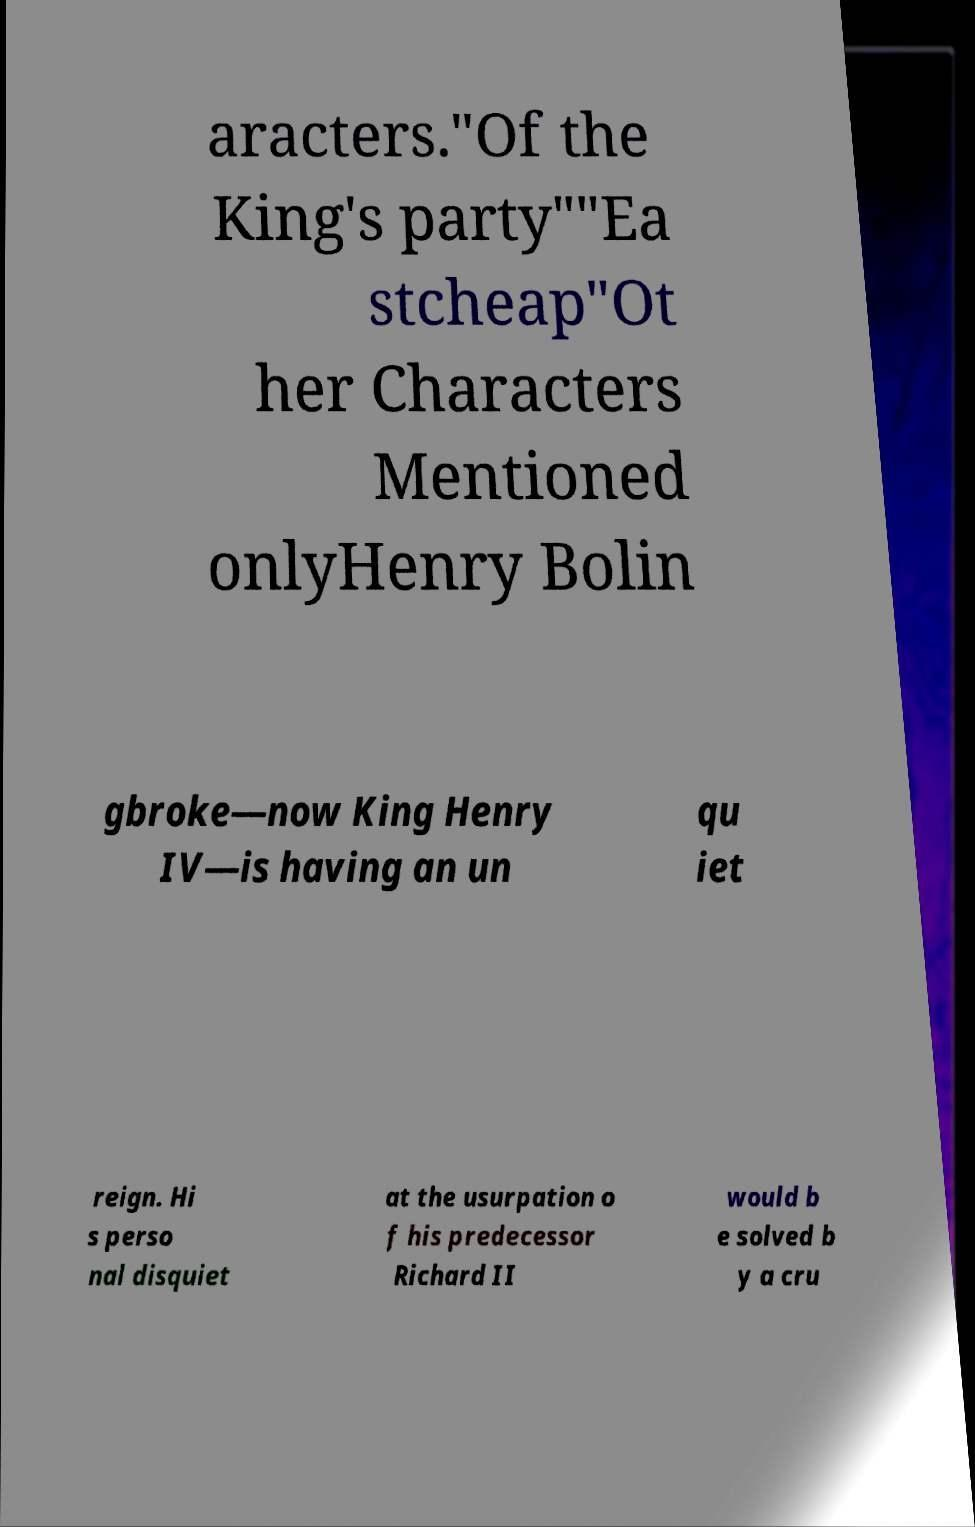Please identify and transcribe the text found in this image. aracters."Of the King's party""Ea stcheap"Ot her Characters Mentioned onlyHenry Bolin gbroke—now King Henry IV—is having an un qu iet reign. Hi s perso nal disquiet at the usurpation o f his predecessor Richard II would b e solved b y a cru 